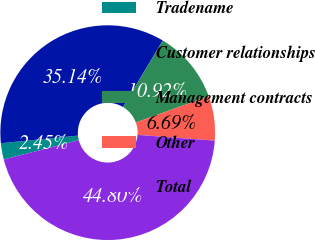Convert chart. <chart><loc_0><loc_0><loc_500><loc_500><pie_chart><fcel>Tradename<fcel>Customer relationships<fcel>Management contracts<fcel>Other<fcel>Total<nl><fcel>2.45%<fcel>35.14%<fcel>10.92%<fcel>6.69%<fcel>44.8%<nl></chart> 